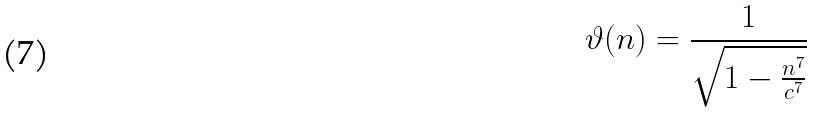<formula> <loc_0><loc_0><loc_500><loc_500>\vartheta ( n ) = \frac { 1 } { \sqrt { 1 - \frac { n ^ { 7 } } { c ^ { 7 } } } }</formula> 